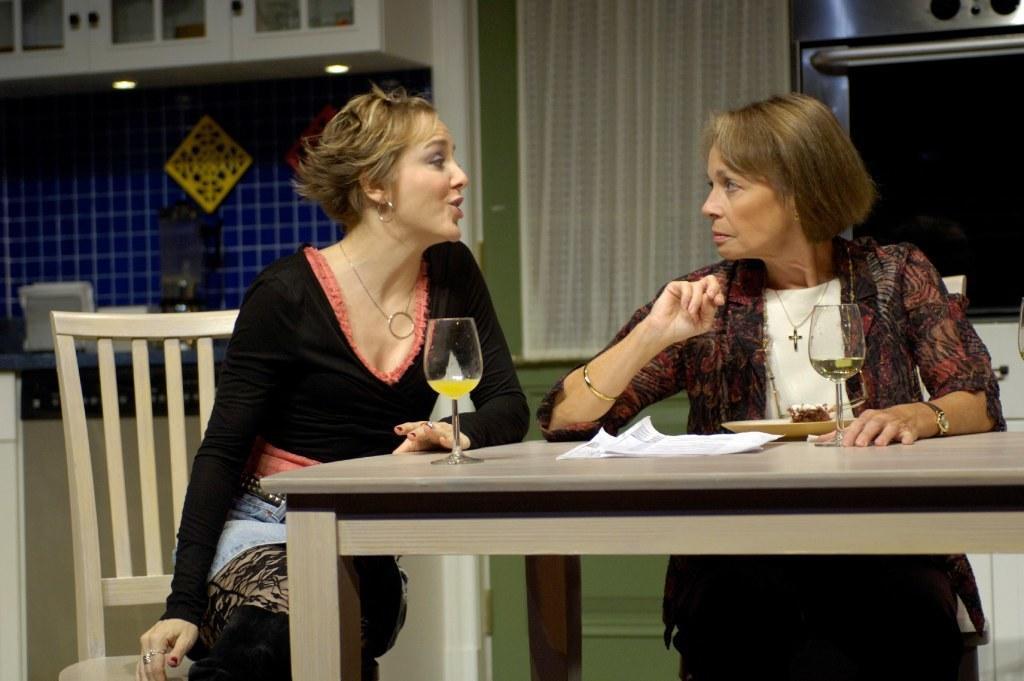How would you summarize this image in a sentence or two? In this image I can see two people sitting in-front of the table. On the table there are glasses,papers and the plate. In the background there is a cupboard and the curtain. 